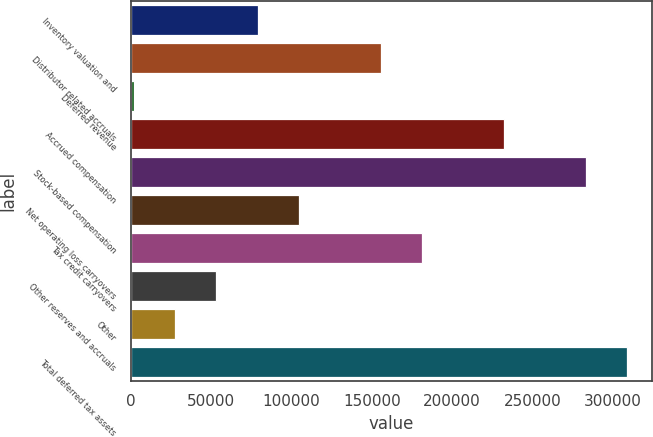<chart> <loc_0><loc_0><loc_500><loc_500><bar_chart><fcel>Inventory valuation and<fcel>Distributor related accruals<fcel>Deferred revenue<fcel>Accrued compensation<fcel>Stock-based compensation<fcel>Net operating loss carryovers<fcel>Tax credit carryovers<fcel>Other reserves and accruals<fcel>Other<fcel>Total deferred tax assets<nl><fcel>78857.2<fcel>155481<fcel>2233<fcel>232106<fcel>283188<fcel>104399<fcel>181023<fcel>53315.8<fcel>27774.4<fcel>308730<nl></chart> 